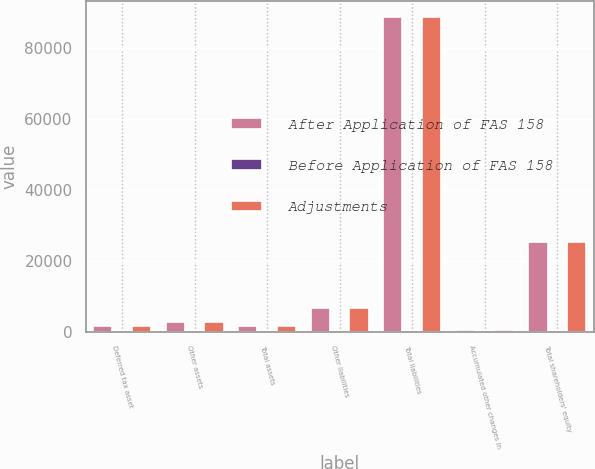Convert chart. <chart><loc_0><loc_0><loc_500><loc_500><stacked_bar_chart><ecel><fcel>Deferred tax asset<fcel>Other assets<fcel>Total assets<fcel>Other liabilities<fcel>Total liabilities<fcel>Accumulated other changes in<fcel>Total shareholders' equity<nl><fcel>After Application of FAS 158<fcel>1493<fcel>2742<fcel>1493<fcel>6674<fcel>88658<fcel>532<fcel>25215<nl><fcel>Before Application of FAS 158<fcel>43<fcel>155<fcel>112<fcel>32<fcel>32<fcel>80<fcel>80<nl><fcel>Adjustments<fcel>1536<fcel>2587<fcel>1493<fcel>6642<fcel>88626<fcel>452<fcel>25135<nl></chart> 